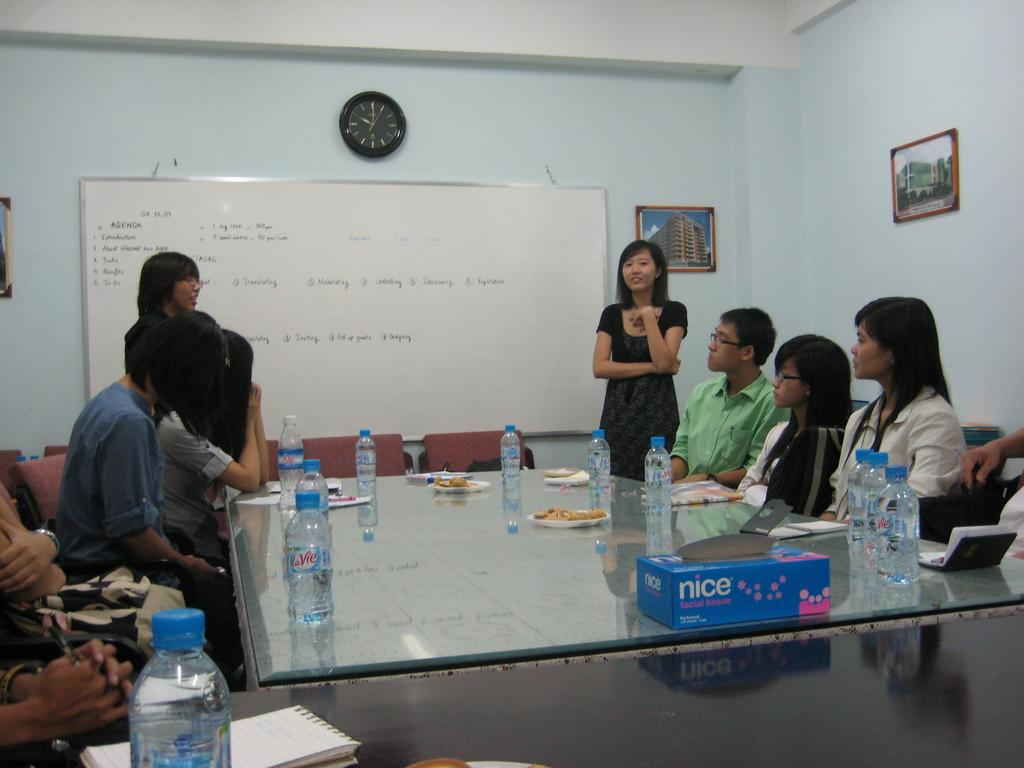<image>
Share a concise interpretation of the image provided. a blue box with the word nice on it 